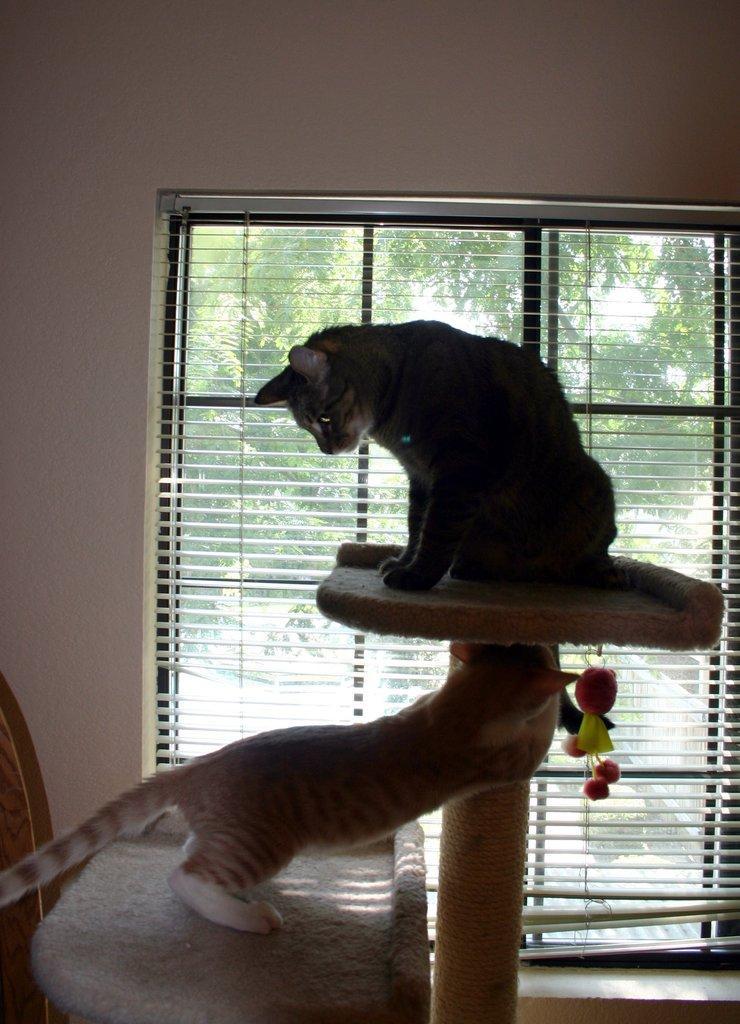In one or two sentences, can you explain what this image depicts? In this picture we can see cats, table, window blind and couple of trees. 